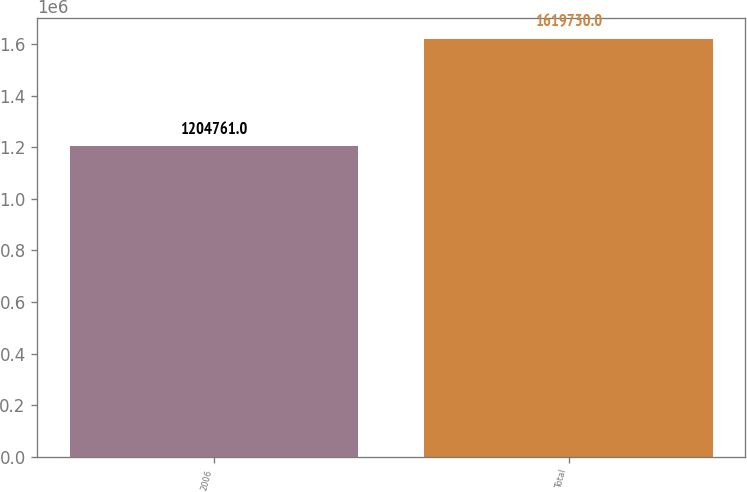Convert chart. <chart><loc_0><loc_0><loc_500><loc_500><bar_chart><fcel>2006<fcel>Total<nl><fcel>1.20476e+06<fcel>1.61973e+06<nl></chart> 